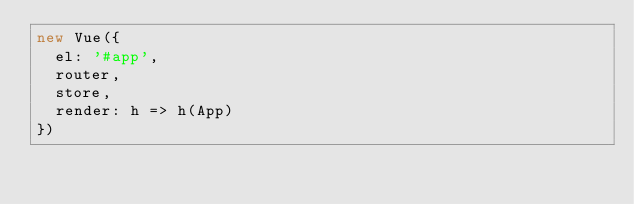Convert code to text. <code><loc_0><loc_0><loc_500><loc_500><_JavaScript_>new Vue({
  el: '#app',
  router,
  store,
  render: h => h(App)
})</code> 